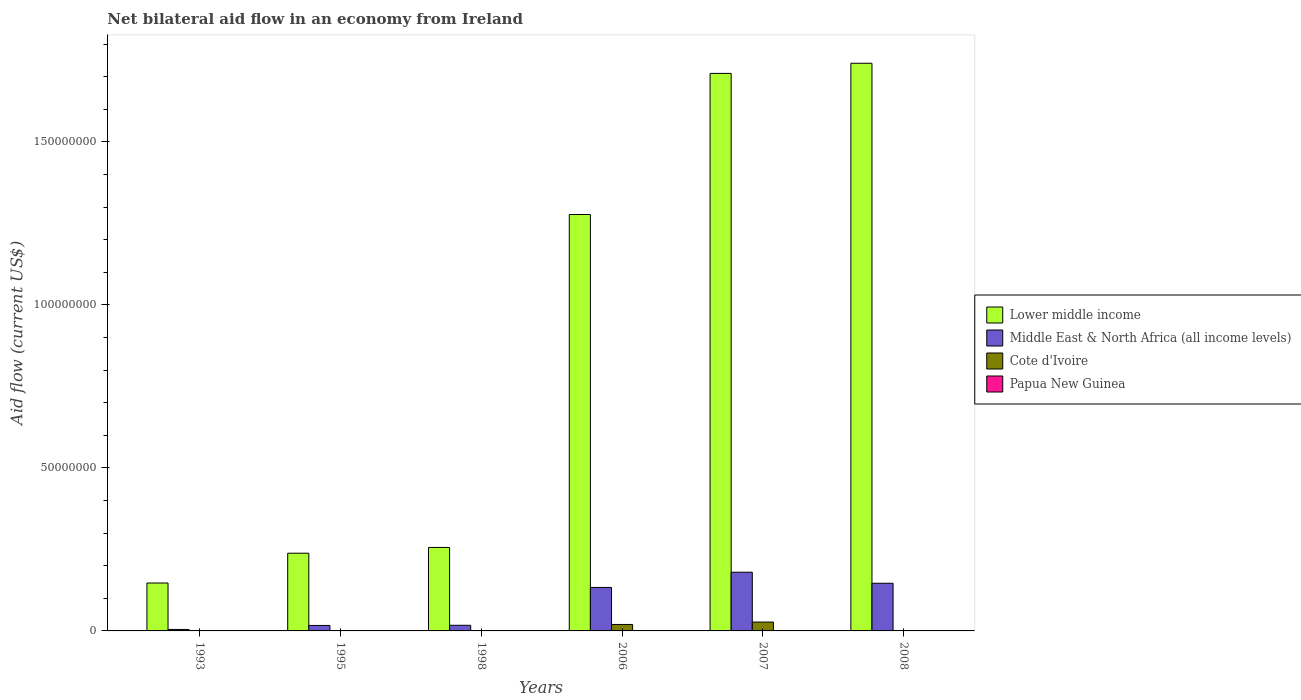How many groups of bars are there?
Provide a succinct answer. 6. Are the number of bars on each tick of the X-axis equal?
Your response must be concise. Yes. How many bars are there on the 3rd tick from the left?
Your response must be concise. 4. What is the net bilateral aid flow in Papua New Guinea in 1993?
Your response must be concise. 10000. Across all years, what is the maximum net bilateral aid flow in Cote d'Ivoire?
Offer a terse response. 2.72e+06. In which year was the net bilateral aid flow in Middle East & North Africa (all income levels) maximum?
Your answer should be compact. 2007. What is the total net bilateral aid flow in Middle East & North Africa (all income levels) in the graph?
Give a very brief answer. 4.98e+07. What is the difference between the net bilateral aid flow in Middle East & North Africa (all income levels) in 1993 and that in 1998?
Provide a succinct answer. -1.28e+06. What is the difference between the net bilateral aid flow in Papua New Guinea in 2008 and the net bilateral aid flow in Lower middle income in 2006?
Provide a short and direct response. -1.28e+08. What is the average net bilateral aid flow in Middle East & North Africa (all income levels) per year?
Your answer should be very brief. 8.30e+06. In the year 2007, what is the difference between the net bilateral aid flow in Papua New Guinea and net bilateral aid flow in Cote d'Ivoire?
Your answer should be very brief. -2.70e+06. In how many years, is the net bilateral aid flow in Middle East & North Africa (all income levels) greater than 50000000 US$?
Offer a very short reply. 0. What is the ratio of the net bilateral aid flow in Middle East & North Africa (all income levels) in 1995 to that in 2007?
Provide a short and direct response. 0.09. Is the difference between the net bilateral aid flow in Papua New Guinea in 1998 and 2006 greater than the difference between the net bilateral aid flow in Cote d'Ivoire in 1998 and 2006?
Make the answer very short. Yes. What is the difference between the highest and the second highest net bilateral aid flow in Cote d'Ivoire?
Keep it short and to the point. 7.40e+05. What is the difference between the highest and the lowest net bilateral aid flow in Cote d'Ivoire?
Your answer should be compact. 2.70e+06. In how many years, is the net bilateral aid flow in Lower middle income greater than the average net bilateral aid flow in Lower middle income taken over all years?
Your answer should be compact. 3. What does the 3rd bar from the left in 2006 represents?
Ensure brevity in your answer.  Cote d'Ivoire. What does the 4th bar from the right in 2008 represents?
Offer a terse response. Lower middle income. Does the graph contain grids?
Your response must be concise. No. What is the title of the graph?
Your answer should be very brief. Net bilateral aid flow in an economy from Ireland. What is the Aid flow (current US$) in Lower middle income in 1993?
Provide a succinct answer. 1.47e+07. What is the Aid flow (current US$) of Middle East & North Africa (all income levels) in 1993?
Offer a terse response. 4.50e+05. What is the Aid flow (current US$) of Cote d'Ivoire in 1993?
Provide a short and direct response. 2.00e+04. What is the Aid flow (current US$) of Papua New Guinea in 1993?
Provide a succinct answer. 10000. What is the Aid flow (current US$) of Lower middle income in 1995?
Offer a very short reply. 2.38e+07. What is the Aid flow (current US$) of Middle East & North Africa (all income levels) in 1995?
Make the answer very short. 1.68e+06. What is the Aid flow (current US$) in Cote d'Ivoire in 1995?
Give a very brief answer. 1.20e+05. What is the Aid flow (current US$) in Papua New Guinea in 1995?
Offer a very short reply. 2.00e+04. What is the Aid flow (current US$) of Lower middle income in 1998?
Keep it short and to the point. 2.56e+07. What is the Aid flow (current US$) in Middle East & North Africa (all income levels) in 1998?
Ensure brevity in your answer.  1.73e+06. What is the Aid flow (current US$) in Lower middle income in 2006?
Keep it short and to the point. 1.28e+08. What is the Aid flow (current US$) in Middle East & North Africa (all income levels) in 2006?
Ensure brevity in your answer.  1.33e+07. What is the Aid flow (current US$) of Cote d'Ivoire in 2006?
Your answer should be compact. 1.98e+06. What is the Aid flow (current US$) in Papua New Guinea in 2006?
Keep it short and to the point. 3.00e+04. What is the Aid flow (current US$) in Lower middle income in 2007?
Keep it short and to the point. 1.71e+08. What is the Aid flow (current US$) in Middle East & North Africa (all income levels) in 2007?
Provide a short and direct response. 1.80e+07. What is the Aid flow (current US$) of Cote d'Ivoire in 2007?
Provide a short and direct response. 2.72e+06. What is the Aid flow (current US$) in Lower middle income in 2008?
Make the answer very short. 1.74e+08. What is the Aid flow (current US$) in Middle East & North Africa (all income levels) in 2008?
Ensure brevity in your answer.  1.46e+07. What is the Aid flow (current US$) in Papua New Guinea in 2008?
Offer a very short reply. 2.00e+04. Across all years, what is the maximum Aid flow (current US$) of Lower middle income?
Make the answer very short. 1.74e+08. Across all years, what is the maximum Aid flow (current US$) in Middle East & North Africa (all income levels)?
Make the answer very short. 1.80e+07. Across all years, what is the maximum Aid flow (current US$) in Cote d'Ivoire?
Provide a succinct answer. 2.72e+06. Across all years, what is the minimum Aid flow (current US$) in Lower middle income?
Ensure brevity in your answer.  1.47e+07. Across all years, what is the minimum Aid flow (current US$) in Cote d'Ivoire?
Ensure brevity in your answer.  2.00e+04. Across all years, what is the minimum Aid flow (current US$) of Papua New Guinea?
Keep it short and to the point. 10000. What is the total Aid flow (current US$) in Lower middle income in the graph?
Offer a very short reply. 5.37e+08. What is the total Aid flow (current US$) of Middle East & North Africa (all income levels) in the graph?
Give a very brief answer. 4.98e+07. What is the total Aid flow (current US$) in Cote d'Ivoire in the graph?
Give a very brief answer. 4.91e+06. What is the total Aid flow (current US$) in Papua New Guinea in the graph?
Ensure brevity in your answer.  1.80e+05. What is the difference between the Aid flow (current US$) of Lower middle income in 1993 and that in 1995?
Make the answer very short. -9.14e+06. What is the difference between the Aid flow (current US$) of Middle East & North Africa (all income levels) in 1993 and that in 1995?
Ensure brevity in your answer.  -1.23e+06. What is the difference between the Aid flow (current US$) in Cote d'Ivoire in 1993 and that in 1995?
Keep it short and to the point. -1.00e+05. What is the difference between the Aid flow (current US$) in Papua New Guinea in 1993 and that in 1995?
Your response must be concise. -10000. What is the difference between the Aid flow (current US$) of Lower middle income in 1993 and that in 1998?
Your answer should be very brief. -1.09e+07. What is the difference between the Aid flow (current US$) of Middle East & North Africa (all income levels) in 1993 and that in 1998?
Provide a succinct answer. -1.28e+06. What is the difference between the Aid flow (current US$) of Cote d'Ivoire in 1993 and that in 1998?
Your response must be concise. 0. What is the difference between the Aid flow (current US$) in Lower middle income in 1993 and that in 2006?
Keep it short and to the point. -1.13e+08. What is the difference between the Aid flow (current US$) of Middle East & North Africa (all income levels) in 1993 and that in 2006?
Your response must be concise. -1.29e+07. What is the difference between the Aid flow (current US$) in Cote d'Ivoire in 1993 and that in 2006?
Offer a terse response. -1.96e+06. What is the difference between the Aid flow (current US$) of Lower middle income in 1993 and that in 2007?
Keep it short and to the point. -1.56e+08. What is the difference between the Aid flow (current US$) of Middle East & North Africa (all income levels) in 1993 and that in 2007?
Provide a short and direct response. -1.76e+07. What is the difference between the Aid flow (current US$) in Cote d'Ivoire in 1993 and that in 2007?
Your answer should be compact. -2.70e+06. What is the difference between the Aid flow (current US$) of Papua New Guinea in 1993 and that in 2007?
Provide a short and direct response. -10000. What is the difference between the Aid flow (current US$) in Lower middle income in 1993 and that in 2008?
Your answer should be compact. -1.59e+08. What is the difference between the Aid flow (current US$) of Middle East & North Africa (all income levels) in 1993 and that in 2008?
Your answer should be very brief. -1.42e+07. What is the difference between the Aid flow (current US$) of Cote d'Ivoire in 1993 and that in 2008?
Your response must be concise. -3.00e+04. What is the difference between the Aid flow (current US$) in Papua New Guinea in 1993 and that in 2008?
Offer a very short reply. -10000. What is the difference between the Aid flow (current US$) in Lower middle income in 1995 and that in 1998?
Your response must be concise. -1.77e+06. What is the difference between the Aid flow (current US$) of Cote d'Ivoire in 1995 and that in 1998?
Ensure brevity in your answer.  1.00e+05. What is the difference between the Aid flow (current US$) of Lower middle income in 1995 and that in 2006?
Your answer should be compact. -1.04e+08. What is the difference between the Aid flow (current US$) of Middle East & North Africa (all income levels) in 1995 and that in 2006?
Offer a very short reply. -1.17e+07. What is the difference between the Aid flow (current US$) of Cote d'Ivoire in 1995 and that in 2006?
Give a very brief answer. -1.86e+06. What is the difference between the Aid flow (current US$) in Papua New Guinea in 1995 and that in 2006?
Make the answer very short. -10000. What is the difference between the Aid flow (current US$) of Lower middle income in 1995 and that in 2007?
Offer a very short reply. -1.47e+08. What is the difference between the Aid flow (current US$) in Middle East & North Africa (all income levels) in 1995 and that in 2007?
Ensure brevity in your answer.  -1.63e+07. What is the difference between the Aid flow (current US$) in Cote d'Ivoire in 1995 and that in 2007?
Give a very brief answer. -2.60e+06. What is the difference between the Aid flow (current US$) in Papua New Guinea in 1995 and that in 2007?
Give a very brief answer. 0. What is the difference between the Aid flow (current US$) in Lower middle income in 1995 and that in 2008?
Keep it short and to the point. -1.50e+08. What is the difference between the Aid flow (current US$) in Middle East & North Africa (all income levels) in 1995 and that in 2008?
Ensure brevity in your answer.  -1.29e+07. What is the difference between the Aid flow (current US$) of Papua New Guinea in 1995 and that in 2008?
Provide a succinct answer. 0. What is the difference between the Aid flow (current US$) in Lower middle income in 1998 and that in 2006?
Your answer should be compact. -1.02e+08. What is the difference between the Aid flow (current US$) in Middle East & North Africa (all income levels) in 1998 and that in 2006?
Keep it short and to the point. -1.16e+07. What is the difference between the Aid flow (current US$) in Cote d'Ivoire in 1998 and that in 2006?
Your answer should be compact. -1.96e+06. What is the difference between the Aid flow (current US$) of Lower middle income in 1998 and that in 2007?
Provide a short and direct response. -1.45e+08. What is the difference between the Aid flow (current US$) in Middle East & North Africa (all income levels) in 1998 and that in 2007?
Your response must be concise. -1.63e+07. What is the difference between the Aid flow (current US$) in Cote d'Ivoire in 1998 and that in 2007?
Offer a very short reply. -2.70e+06. What is the difference between the Aid flow (current US$) in Lower middle income in 1998 and that in 2008?
Your answer should be very brief. -1.49e+08. What is the difference between the Aid flow (current US$) in Middle East & North Africa (all income levels) in 1998 and that in 2008?
Your answer should be very brief. -1.29e+07. What is the difference between the Aid flow (current US$) of Papua New Guinea in 1998 and that in 2008?
Provide a succinct answer. 6.00e+04. What is the difference between the Aid flow (current US$) in Lower middle income in 2006 and that in 2007?
Offer a very short reply. -4.33e+07. What is the difference between the Aid flow (current US$) of Middle East & North Africa (all income levels) in 2006 and that in 2007?
Offer a terse response. -4.67e+06. What is the difference between the Aid flow (current US$) in Cote d'Ivoire in 2006 and that in 2007?
Keep it short and to the point. -7.40e+05. What is the difference between the Aid flow (current US$) of Lower middle income in 2006 and that in 2008?
Give a very brief answer. -4.64e+07. What is the difference between the Aid flow (current US$) of Middle East & North Africa (all income levels) in 2006 and that in 2008?
Keep it short and to the point. -1.28e+06. What is the difference between the Aid flow (current US$) in Cote d'Ivoire in 2006 and that in 2008?
Provide a succinct answer. 1.93e+06. What is the difference between the Aid flow (current US$) in Papua New Guinea in 2006 and that in 2008?
Give a very brief answer. 10000. What is the difference between the Aid flow (current US$) in Lower middle income in 2007 and that in 2008?
Keep it short and to the point. -3.11e+06. What is the difference between the Aid flow (current US$) of Middle East & North Africa (all income levels) in 2007 and that in 2008?
Offer a terse response. 3.39e+06. What is the difference between the Aid flow (current US$) in Cote d'Ivoire in 2007 and that in 2008?
Your response must be concise. 2.67e+06. What is the difference between the Aid flow (current US$) of Papua New Guinea in 2007 and that in 2008?
Ensure brevity in your answer.  0. What is the difference between the Aid flow (current US$) in Lower middle income in 1993 and the Aid flow (current US$) in Middle East & North Africa (all income levels) in 1995?
Offer a very short reply. 1.30e+07. What is the difference between the Aid flow (current US$) in Lower middle income in 1993 and the Aid flow (current US$) in Cote d'Ivoire in 1995?
Make the answer very short. 1.46e+07. What is the difference between the Aid flow (current US$) of Lower middle income in 1993 and the Aid flow (current US$) of Papua New Guinea in 1995?
Your answer should be compact. 1.47e+07. What is the difference between the Aid flow (current US$) in Cote d'Ivoire in 1993 and the Aid flow (current US$) in Papua New Guinea in 1995?
Make the answer very short. 0. What is the difference between the Aid flow (current US$) of Lower middle income in 1993 and the Aid flow (current US$) of Middle East & North Africa (all income levels) in 1998?
Make the answer very short. 1.30e+07. What is the difference between the Aid flow (current US$) of Lower middle income in 1993 and the Aid flow (current US$) of Cote d'Ivoire in 1998?
Provide a short and direct response. 1.47e+07. What is the difference between the Aid flow (current US$) of Lower middle income in 1993 and the Aid flow (current US$) of Papua New Guinea in 1998?
Provide a succinct answer. 1.46e+07. What is the difference between the Aid flow (current US$) in Lower middle income in 1993 and the Aid flow (current US$) in Middle East & North Africa (all income levels) in 2006?
Ensure brevity in your answer.  1.36e+06. What is the difference between the Aid flow (current US$) of Lower middle income in 1993 and the Aid flow (current US$) of Cote d'Ivoire in 2006?
Provide a succinct answer. 1.27e+07. What is the difference between the Aid flow (current US$) of Lower middle income in 1993 and the Aid flow (current US$) of Papua New Guinea in 2006?
Your answer should be very brief. 1.47e+07. What is the difference between the Aid flow (current US$) in Middle East & North Africa (all income levels) in 1993 and the Aid flow (current US$) in Cote d'Ivoire in 2006?
Your response must be concise. -1.53e+06. What is the difference between the Aid flow (current US$) in Middle East & North Africa (all income levels) in 1993 and the Aid flow (current US$) in Papua New Guinea in 2006?
Make the answer very short. 4.20e+05. What is the difference between the Aid flow (current US$) in Cote d'Ivoire in 1993 and the Aid flow (current US$) in Papua New Guinea in 2006?
Give a very brief answer. -10000. What is the difference between the Aid flow (current US$) in Lower middle income in 1993 and the Aid flow (current US$) in Middle East & North Africa (all income levels) in 2007?
Provide a short and direct response. -3.31e+06. What is the difference between the Aid flow (current US$) of Lower middle income in 1993 and the Aid flow (current US$) of Cote d'Ivoire in 2007?
Provide a succinct answer. 1.20e+07. What is the difference between the Aid flow (current US$) in Lower middle income in 1993 and the Aid flow (current US$) in Papua New Guinea in 2007?
Give a very brief answer. 1.47e+07. What is the difference between the Aid flow (current US$) of Middle East & North Africa (all income levels) in 1993 and the Aid flow (current US$) of Cote d'Ivoire in 2007?
Provide a succinct answer. -2.27e+06. What is the difference between the Aid flow (current US$) of Lower middle income in 1993 and the Aid flow (current US$) of Cote d'Ivoire in 2008?
Make the answer very short. 1.46e+07. What is the difference between the Aid flow (current US$) in Lower middle income in 1993 and the Aid flow (current US$) in Papua New Guinea in 2008?
Your answer should be compact. 1.47e+07. What is the difference between the Aid flow (current US$) in Middle East & North Africa (all income levels) in 1993 and the Aid flow (current US$) in Cote d'Ivoire in 2008?
Your response must be concise. 4.00e+05. What is the difference between the Aid flow (current US$) in Cote d'Ivoire in 1993 and the Aid flow (current US$) in Papua New Guinea in 2008?
Give a very brief answer. 0. What is the difference between the Aid flow (current US$) in Lower middle income in 1995 and the Aid flow (current US$) in Middle East & North Africa (all income levels) in 1998?
Give a very brief answer. 2.21e+07. What is the difference between the Aid flow (current US$) of Lower middle income in 1995 and the Aid flow (current US$) of Cote d'Ivoire in 1998?
Provide a succinct answer. 2.38e+07. What is the difference between the Aid flow (current US$) in Lower middle income in 1995 and the Aid flow (current US$) in Papua New Guinea in 1998?
Offer a terse response. 2.38e+07. What is the difference between the Aid flow (current US$) in Middle East & North Africa (all income levels) in 1995 and the Aid flow (current US$) in Cote d'Ivoire in 1998?
Offer a very short reply. 1.66e+06. What is the difference between the Aid flow (current US$) in Middle East & North Africa (all income levels) in 1995 and the Aid flow (current US$) in Papua New Guinea in 1998?
Ensure brevity in your answer.  1.60e+06. What is the difference between the Aid flow (current US$) in Lower middle income in 1995 and the Aid flow (current US$) in Middle East & North Africa (all income levels) in 2006?
Offer a very short reply. 1.05e+07. What is the difference between the Aid flow (current US$) in Lower middle income in 1995 and the Aid flow (current US$) in Cote d'Ivoire in 2006?
Provide a short and direct response. 2.19e+07. What is the difference between the Aid flow (current US$) of Lower middle income in 1995 and the Aid flow (current US$) of Papua New Guinea in 2006?
Your response must be concise. 2.38e+07. What is the difference between the Aid flow (current US$) of Middle East & North Africa (all income levels) in 1995 and the Aid flow (current US$) of Cote d'Ivoire in 2006?
Make the answer very short. -3.00e+05. What is the difference between the Aid flow (current US$) in Middle East & North Africa (all income levels) in 1995 and the Aid flow (current US$) in Papua New Guinea in 2006?
Your answer should be compact. 1.65e+06. What is the difference between the Aid flow (current US$) of Cote d'Ivoire in 1995 and the Aid flow (current US$) of Papua New Guinea in 2006?
Your answer should be compact. 9.00e+04. What is the difference between the Aid flow (current US$) of Lower middle income in 1995 and the Aid flow (current US$) of Middle East & North Africa (all income levels) in 2007?
Provide a succinct answer. 5.83e+06. What is the difference between the Aid flow (current US$) in Lower middle income in 1995 and the Aid flow (current US$) in Cote d'Ivoire in 2007?
Offer a terse response. 2.11e+07. What is the difference between the Aid flow (current US$) in Lower middle income in 1995 and the Aid flow (current US$) in Papua New Guinea in 2007?
Ensure brevity in your answer.  2.38e+07. What is the difference between the Aid flow (current US$) in Middle East & North Africa (all income levels) in 1995 and the Aid flow (current US$) in Cote d'Ivoire in 2007?
Keep it short and to the point. -1.04e+06. What is the difference between the Aid flow (current US$) in Middle East & North Africa (all income levels) in 1995 and the Aid flow (current US$) in Papua New Guinea in 2007?
Give a very brief answer. 1.66e+06. What is the difference between the Aid flow (current US$) in Lower middle income in 1995 and the Aid flow (current US$) in Middle East & North Africa (all income levels) in 2008?
Provide a succinct answer. 9.22e+06. What is the difference between the Aid flow (current US$) in Lower middle income in 1995 and the Aid flow (current US$) in Cote d'Ivoire in 2008?
Provide a succinct answer. 2.38e+07. What is the difference between the Aid flow (current US$) of Lower middle income in 1995 and the Aid flow (current US$) of Papua New Guinea in 2008?
Provide a succinct answer. 2.38e+07. What is the difference between the Aid flow (current US$) of Middle East & North Africa (all income levels) in 1995 and the Aid flow (current US$) of Cote d'Ivoire in 2008?
Provide a short and direct response. 1.63e+06. What is the difference between the Aid flow (current US$) in Middle East & North Africa (all income levels) in 1995 and the Aid flow (current US$) in Papua New Guinea in 2008?
Your response must be concise. 1.66e+06. What is the difference between the Aid flow (current US$) of Cote d'Ivoire in 1995 and the Aid flow (current US$) of Papua New Guinea in 2008?
Ensure brevity in your answer.  1.00e+05. What is the difference between the Aid flow (current US$) of Lower middle income in 1998 and the Aid flow (current US$) of Middle East & North Africa (all income levels) in 2006?
Give a very brief answer. 1.23e+07. What is the difference between the Aid flow (current US$) in Lower middle income in 1998 and the Aid flow (current US$) in Cote d'Ivoire in 2006?
Provide a short and direct response. 2.36e+07. What is the difference between the Aid flow (current US$) of Lower middle income in 1998 and the Aid flow (current US$) of Papua New Guinea in 2006?
Provide a succinct answer. 2.56e+07. What is the difference between the Aid flow (current US$) of Middle East & North Africa (all income levels) in 1998 and the Aid flow (current US$) of Cote d'Ivoire in 2006?
Offer a very short reply. -2.50e+05. What is the difference between the Aid flow (current US$) of Middle East & North Africa (all income levels) in 1998 and the Aid flow (current US$) of Papua New Guinea in 2006?
Keep it short and to the point. 1.70e+06. What is the difference between the Aid flow (current US$) in Lower middle income in 1998 and the Aid flow (current US$) in Middle East & North Africa (all income levels) in 2007?
Your answer should be very brief. 7.60e+06. What is the difference between the Aid flow (current US$) of Lower middle income in 1998 and the Aid flow (current US$) of Cote d'Ivoire in 2007?
Offer a very short reply. 2.29e+07. What is the difference between the Aid flow (current US$) in Lower middle income in 1998 and the Aid flow (current US$) in Papua New Guinea in 2007?
Keep it short and to the point. 2.56e+07. What is the difference between the Aid flow (current US$) of Middle East & North Africa (all income levels) in 1998 and the Aid flow (current US$) of Cote d'Ivoire in 2007?
Your response must be concise. -9.90e+05. What is the difference between the Aid flow (current US$) in Middle East & North Africa (all income levels) in 1998 and the Aid flow (current US$) in Papua New Guinea in 2007?
Provide a succinct answer. 1.71e+06. What is the difference between the Aid flow (current US$) in Lower middle income in 1998 and the Aid flow (current US$) in Middle East & North Africa (all income levels) in 2008?
Your answer should be very brief. 1.10e+07. What is the difference between the Aid flow (current US$) of Lower middle income in 1998 and the Aid flow (current US$) of Cote d'Ivoire in 2008?
Offer a very short reply. 2.56e+07. What is the difference between the Aid flow (current US$) of Lower middle income in 1998 and the Aid flow (current US$) of Papua New Guinea in 2008?
Offer a very short reply. 2.56e+07. What is the difference between the Aid flow (current US$) in Middle East & North Africa (all income levels) in 1998 and the Aid flow (current US$) in Cote d'Ivoire in 2008?
Provide a short and direct response. 1.68e+06. What is the difference between the Aid flow (current US$) in Middle East & North Africa (all income levels) in 1998 and the Aid flow (current US$) in Papua New Guinea in 2008?
Give a very brief answer. 1.71e+06. What is the difference between the Aid flow (current US$) in Lower middle income in 2006 and the Aid flow (current US$) in Middle East & North Africa (all income levels) in 2007?
Provide a succinct answer. 1.10e+08. What is the difference between the Aid flow (current US$) of Lower middle income in 2006 and the Aid flow (current US$) of Cote d'Ivoire in 2007?
Keep it short and to the point. 1.25e+08. What is the difference between the Aid flow (current US$) of Lower middle income in 2006 and the Aid flow (current US$) of Papua New Guinea in 2007?
Offer a terse response. 1.28e+08. What is the difference between the Aid flow (current US$) of Middle East & North Africa (all income levels) in 2006 and the Aid flow (current US$) of Cote d'Ivoire in 2007?
Offer a terse response. 1.06e+07. What is the difference between the Aid flow (current US$) of Middle East & North Africa (all income levels) in 2006 and the Aid flow (current US$) of Papua New Guinea in 2007?
Your answer should be very brief. 1.33e+07. What is the difference between the Aid flow (current US$) in Cote d'Ivoire in 2006 and the Aid flow (current US$) in Papua New Guinea in 2007?
Your answer should be compact. 1.96e+06. What is the difference between the Aid flow (current US$) of Lower middle income in 2006 and the Aid flow (current US$) of Middle East & North Africa (all income levels) in 2008?
Make the answer very short. 1.13e+08. What is the difference between the Aid flow (current US$) in Lower middle income in 2006 and the Aid flow (current US$) in Cote d'Ivoire in 2008?
Give a very brief answer. 1.28e+08. What is the difference between the Aid flow (current US$) in Lower middle income in 2006 and the Aid flow (current US$) in Papua New Guinea in 2008?
Make the answer very short. 1.28e+08. What is the difference between the Aid flow (current US$) of Middle East & North Africa (all income levels) in 2006 and the Aid flow (current US$) of Cote d'Ivoire in 2008?
Provide a succinct answer. 1.33e+07. What is the difference between the Aid flow (current US$) in Middle East & North Africa (all income levels) in 2006 and the Aid flow (current US$) in Papua New Guinea in 2008?
Offer a very short reply. 1.33e+07. What is the difference between the Aid flow (current US$) in Cote d'Ivoire in 2006 and the Aid flow (current US$) in Papua New Guinea in 2008?
Offer a very short reply. 1.96e+06. What is the difference between the Aid flow (current US$) in Lower middle income in 2007 and the Aid flow (current US$) in Middle East & North Africa (all income levels) in 2008?
Your answer should be compact. 1.56e+08. What is the difference between the Aid flow (current US$) of Lower middle income in 2007 and the Aid flow (current US$) of Cote d'Ivoire in 2008?
Make the answer very short. 1.71e+08. What is the difference between the Aid flow (current US$) in Lower middle income in 2007 and the Aid flow (current US$) in Papua New Guinea in 2008?
Your answer should be very brief. 1.71e+08. What is the difference between the Aid flow (current US$) of Middle East & North Africa (all income levels) in 2007 and the Aid flow (current US$) of Cote d'Ivoire in 2008?
Provide a short and direct response. 1.80e+07. What is the difference between the Aid flow (current US$) in Middle East & North Africa (all income levels) in 2007 and the Aid flow (current US$) in Papua New Guinea in 2008?
Give a very brief answer. 1.80e+07. What is the difference between the Aid flow (current US$) of Cote d'Ivoire in 2007 and the Aid flow (current US$) of Papua New Guinea in 2008?
Offer a terse response. 2.70e+06. What is the average Aid flow (current US$) in Lower middle income per year?
Give a very brief answer. 8.95e+07. What is the average Aid flow (current US$) of Middle East & North Africa (all income levels) per year?
Give a very brief answer. 8.30e+06. What is the average Aid flow (current US$) in Cote d'Ivoire per year?
Provide a succinct answer. 8.18e+05. What is the average Aid flow (current US$) of Papua New Guinea per year?
Make the answer very short. 3.00e+04. In the year 1993, what is the difference between the Aid flow (current US$) of Lower middle income and Aid flow (current US$) of Middle East & North Africa (all income levels)?
Give a very brief answer. 1.42e+07. In the year 1993, what is the difference between the Aid flow (current US$) in Lower middle income and Aid flow (current US$) in Cote d'Ivoire?
Your answer should be compact. 1.47e+07. In the year 1993, what is the difference between the Aid flow (current US$) in Lower middle income and Aid flow (current US$) in Papua New Guinea?
Your answer should be compact. 1.47e+07. In the year 1993, what is the difference between the Aid flow (current US$) in Middle East & North Africa (all income levels) and Aid flow (current US$) in Papua New Guinea?
Your answer should be very brief. 4.40e+05. In the year 1995, what is the difference between the Aid flow (current US$) of Lower middle income and Aid flow (current US$) of Middle East & North Africa (all income levels)?
Keep it short and to the point. 2.22e+07. In the year 1995, what is the difference between the Aid flow (current US$) in Lower middle income and Aid flow (current US$) in Cote d'Ivoire?
Your answer should be very brief. 2.37e+07. In the year 1995, what is the difference between the Aid flow (current US$) in Lower middle income and Aid flow (current US$) in Papua New Guinea?
Give a very brief answer. 2.38e+07. In the year 1995, what is the difference between the Aid flow (current US$) in Middle East & North Africa (all income levels) and Aid flow (current US$) in Cote d'Ivoire?
Give a very brief answer. 1.56e+06. In the year 1995, what is the difference between the Aid flow (current US$) of Middle East & North Africa (all income levels) and Aid flow (current US$) of Papua New Guinea?
Your answer should be very brief. 1.66e+06. In the year 1998, what is the difference between the Aid flow (current US$) of Lower middle income and Aid flow (current US$) of Middle East & North Africa (all income levels)?
Make the answer very short. 2.39e+07. In the year 1998, what is the difference between the Aid flow (current US$) in Lower middle income and Aid flow (current US$) in Cote d'Ivoire?
Your response must be concise. 2.56e+07. In the year 1998, what is the difference between the Aid flow (current US$) of Lower middle income and Aid flow (current US$) of Papua New Guinea?
Your response must be concise. 2.55e+07. In the year 1998, what is the difference between the Aid flow (current US$) of Middle East & North Africa (all income levels) and Aid flow (current US$) of Cote d'Ivoire?
Offer a very short reply. 1.71e+06. In the year 1998, what is the difference between the Aid flow (current US$) in Middle East & North Africa (all income levels) and Aid flow (current US$) in Papua New Guinea?
Offer a very short reply. 1.65e+06. In the year 1998, what is the difference between the Aid flow (current US$) of Cote d'Ivoire and Aid flow (current US$) of Papua New Guinea?
Provide a succinct answer. -6.00e+04. In the year 2006, what is the difference between the Aid flow (current US$) in Lower middle income and Aid flow (current US$) in Middle East & North Africa (all income levels)?
Your answer should be very brief. 1.14e+08. In the year 2006, what is the difference between the Aid flow (current US$) of Lower middle income and Aid flow (current US$) of Cote d'Ivoire?
Provide a succinct answer. 1.26e+08. In the year 2006, what is the difference between the Aid flow (current US$) in Lower middle income and Aid flow (current US$) in Papua New Guinea?
Your answer should be compact. 1.28e+08. In the year 2006, what is the difference between the Aid flow (current US$) in Middle East & North Africa (all income levels) and Aid flow (current US$) in Cote d'Ivoire?
Your response must be concise. 1.14e+07. In the year 2006, what is the difference between the Aid flow (current US$) in Middle East & North Africa (all income levels) and Aid flow (current US$) in Papua New Guinea?
Make the answer very short. 1.33e+07. In the year 2006, what is the difference between the Aid flow (current US$) in Cote d'Ivoire and Aid flow (current US$) in Papua New Guinea?
Ensure brevity in your answer.  1.95e+06. In the year 2007, what is the difference between the Aid flow (current US$) of Lower middle income and Aid flow (current US$) of Middle East & North Africa (all income levels)?
Your response must be concise. 1.53e+08. In the year 2007, what is the difference between the Aid flow (current US$) in Lower middle income and Aid flow (current US$) in Cote d'Ivoire?
Offer a terse response. 1.68e+08. In the year 2007, what is the difference between the Aid flow (current US$) of Lower middle income and Aid flow (current US$) of Papua New Guinea?
Make the answer very short. 1.71e+08. In the year 2007, what is the difference between the Aid flow (current US$) in Middle East & North Africa (all income levels) and Aid flow (current US$) in Cote d'Ivoire?
Offer a very short reply. 1.53e+07. In the year 2007, what is the difference between the Aid flow (current US$) in Middle East & North Africa (all income levels) and Aid flow (current US$) in Papua New Guinea?
Your answer should be very brief. 1.80e+07. In the year 2007, what is the difference between the Aid flow (current US$) of Cote d'Ivoire and Aid flow (current US$) of Papua New Guinea?
Give a very brief answer. 2.70e+06. In the year 2008, what is the difference between the Aid flow (current US$) of Lower middle income and Aid flow (current US$) of Middle East & North Africa (all income levels)?
Your answer should be compact. 1.60e+08. In the year 2008, what is the difference between the Aid flow (current US$) of Lower middle income and Aid flow (current US$) of Cote d'Ivoire?
Your answer should be very brief. 1.74e+08. In the year 2008, what is the difference between the Aid flow (current US$) in Lower middle income and Aid flow (current US$) in Papua New Guinea?
Your answer should be very brief. 1.74e+08. In the year 2008, what is the difference between the Aid flow (current US$) of Middle East & North Africa (all income levels) and Aid flow (current US$) of Cote d'Ivoire?
Provide a succinct answer. 1.46e+07. In the year 2008, what is the difference between the Aid flow (current US$) in Middle East & North Africa (all income levels) and Aid flow (current US$) in Papua New Guinea?
Make the answer very short. 1.46e+07. What is the ratio of the Aid flow (current US$) in Lower middle income in 1993 to that in 1995?
Offer a terse response. 0.62. What is the ratio of the Aid flow (current US$) in Middle East & North Africa (all income levels) in 1993 to that in 1995?
Your response must be concise. 0.27. What is the ratio of the Aid flow (current US$) in Papua New Guinea in 1993 to that in 1995?
Give a very brief answer. 0.5. What is the ratio of the Aid flow (current US$) of Lower middle income in 1993 to that in 1998?
Keep it short and to the point. 0.57. What is the ratio of the Aid flow (current US$) of Middle East & North Africa (all income levels) in 1993 to that in 1998?
Provide a succinct answer. 0.26. What is the ratio of the Aid flow (current US$) of Cote d'Ivoire in 1993 to that in 1998?
Provide a succinct answer. 1. What is the ratio of the Aid flow (current US$) in Papua New Guinea in 1993 to that in 1998?
Keep it short and to the point. 0.12. What is the ratio of the Aid flow (current US$) in Lower middle income in 1993 to that in 2006?
Give a very brief answer. 0.12. What is the ratio of the Aid flow (current US$) of Middle East & North Africa (all income levels) in 1993 to that in 2006?
Your response must be concise. 0.03. What is the ratio of the Aid flow (current US$) of Cote d'Ivoire in 1993 to that in 2006?
Make the answer very short. 0.01. What is the ratio of the Aid flow (current US$) in Lower middle income in 1993 to that in 2007?
Keep it short and to the point. 0.09. What is the ratio of the Aid flow (current US$) of Middle East & North Africa (all income levels) in 1993 to that in 2007?
Offer a terse response. 0.03. What is the ratio of the Aid flow (current US$) of Cote d'Ivoire in 1993 to that in 2007?
Give a very brief answer. 0.01. What is the ratio of the Aid flow (current US$) of Lower middle income in 1993 to that in 2008?
Ensure brevity in your answer.  0.08. What is the ratio of the Aid flow (current US$) of Middle East & North Africa (all income levels) in 1993 to that in 2008?
Your response must be concise. 0.03. What is the ratio of the Aid flow (current US$) of Lower middle income in 1995 to that in 1998?
Give a very brief answer. 0.93. What is the ratio of the Aid flow (current US$) of Middle East & North Africa (all income levels) in 1995 to that in 1998?
Your answer should be compact. 0.97. What is the ratio of the Aid flow (current US$) in Cote d'Ivoire in 1995 to that in 1998?
Provide a succinct answer. 6. What is the ratio of the Aid flow (current US$) of Papua New Guinea in 1995 to that in 1998?
Your answer should be very brief. 0.25. What is the ratio of the Aid flow (current US$) in Lower middle income in 1995 to that in 2006?
Make the answer very short. 0.19. What is the ratio of the Aid flow (current US$) of Middle East & North Africa (all income levels) in 1995 to that in 2006?
Make the answer very short. 0.13. What is the ratio of the Aid flow (current US$) of Cote d'Ivoire in 1995 to that in 2006?
Your response must be concise. 0.06. What is the ratio of the Aid flow (current US$) of Papua New Guinea in 1995 to that in 2006?
Give a very brief answer. 0.67. What is the ratio of the Aid flow (current US$) of Lower middle income in 1995 to that in 2007?
Your answer should be compact. 0.14. What is the ratio of the Aid flow (current US$) of Middle East & North Africa (all income levels) in 1995 to that in 2007?
Ensure brevity in your answer.  0.09. What is the ratio of the Aid flow (current US$) in Cote d'Ivoire in 1995 to that in 2007?
Offer a terse response. 0.04. What is the ratio of the Aid flow (current US$) in Lower middle income in 1995 to that in 2008?
Provide a short and direct response. 0.14. What is the ratio of the Aid flow (current US$) of Middle East & North Africa (all income levels) in 1995 to that in 2008?
Keep it short and to the point. 0.11. What is the ratio of the Aid flow (current US$) in Cote d'Ivoire in 1995 to that in 2008?
Give a very brief answer. 2.4. What is the ratio of the Aid flow (current US$) of Papua New Guinea in 1995 to that in 2008?
Provide a succinct answer. 1. What is the ratio of the Aid flow (current US$) of Lower middle income in 1998 to that in 2006?
Offer a very short reply. 0.2. What is the ratio of the Aid flow (current US$) in Middle East & North Africa (all income levels) in 1998 to that in 2006?
Provide a short and direct response. 0.13. What is the ratio of the Aid flow (current US$) in Cote d'Ivoire in 1998 to that in 2006?
Your answer should be very brief. 0.01. What is the ratio of the Aid flow (current US$) in Papua New Guinea in 1998 to that in 2006?
Your response must be concise. 2.67. What is the ratio of the Aid flow (current US$) in Lower middle income in 1998 to that in 2007?
Provide a succinct answer. 0.15. What is the ratio of the Aid flow (current US$) in Middle East & North Africa (all income levels) in 1998 to that in 2007?
Offer a terse response. 0.1. What is the ratio of the Aid flow (current US$) of Cote d'Ivoire in 1998 to that in 2007?
Offer a terse response. 0.01. What is the ratio of the Aid flow (current US$) of Papua New Guinea in 1998 to that in 2007?
Make the answer very short. 4. What is the ratio of the Aid flow (current US$) in Lower middle income in 1998 to that in 2008?
Your answer should be very brief. 0.15. What is the ratio of the Aid flow (current US$) of Middle East & North Africa (all income levels) in 1998 to that in 2008?
Make the answer very short. 0.12. What is the ratio of the Aid flow (current US$) of Cote d'Ivoire in 1998 to that in 2008?
Offer a very short reply. 0.4. What is the ratio of the Aid flow (current US$) of Lower middle income in 2006 to that in 2007?
Provide a short and direct response. 0.75. What is the ratio of the Aid flow (current US$) in Middle East & North Africa (all income levels) in 2006 to that in 2007?
Your answer should be very brief. 0.74. What is the ratio of the Aid flow (current US$) of Cote d'Ivoire in 2006 to that in 2007?
Ensure brevity in your answer.  0.73. What is the ratio of the Aid flow (current US$) in Lower middle income in 2006 to that in 2008?
Provide a short and direct response. 0.73. What is the ratio of the Aid flow (current US$) of Middle East & North Africa (all income levels) in 2006 to that in 2008?
Make the answer very short. 0.91. What is the ratio of the Aid flow (current US$) of Cote d'Ivoire in 2006 to that in 2008?
Offer a terse response. 39.6. What is the ratio of the Aid flow (current US$) of Papua New Guinea in 2006 to that in 2008?
Ensure brevity in your answer.  1.5. What is the ratio of the Aid flow (current US$) of Lower middle income in 2007 to that in 2008?
Ensure brevity in your answer.  0.98. What is the ratio of the Aid flow (current US$) in Middle East & North Africa (all income levels) in 2007 to that in 2008?
Ensure brevity in your answer.  1.23. What is the ratio of the Aid flow (current US$) in Cote d'Ivoire in 2007 to that in 2008?
Your response must be concise. 54.4. What is the difference between the highest and the second highest Aid flow (current US$) of Lower middle income?
Your answer should be compact. 3.11e+06. What is the difference between the highest and the second highest Aid flow (current US$) of Middle East & North Africa (all income levels)?
Your answer should be compact. 3.39e+06. What is the difference between the highest and the second highest Aid flow (current US$) of Cote d'Ivoire?
Your response must be concise. 7.40e+05. What is the difference between the highest and the lowest Aid flow (current US$) in Lower middle income?
Make the answer very short. 1.59e+08. What is the difference between the highest and the lowest Aid flow (current US$) in Middle East & North Africa (all income levels)?
Ensure brevity in your answer.  1.76e+07. What is the difference between the highest and the lowest Aid flow (current US$) of Cote d'Ivoire?
Give a very brief answer. 2.70e+06. What is the difference between the highest and the lowest Aid flow (current US$) in Papua New Guinea?
Provide a short and direct response. 7.00e+04. 